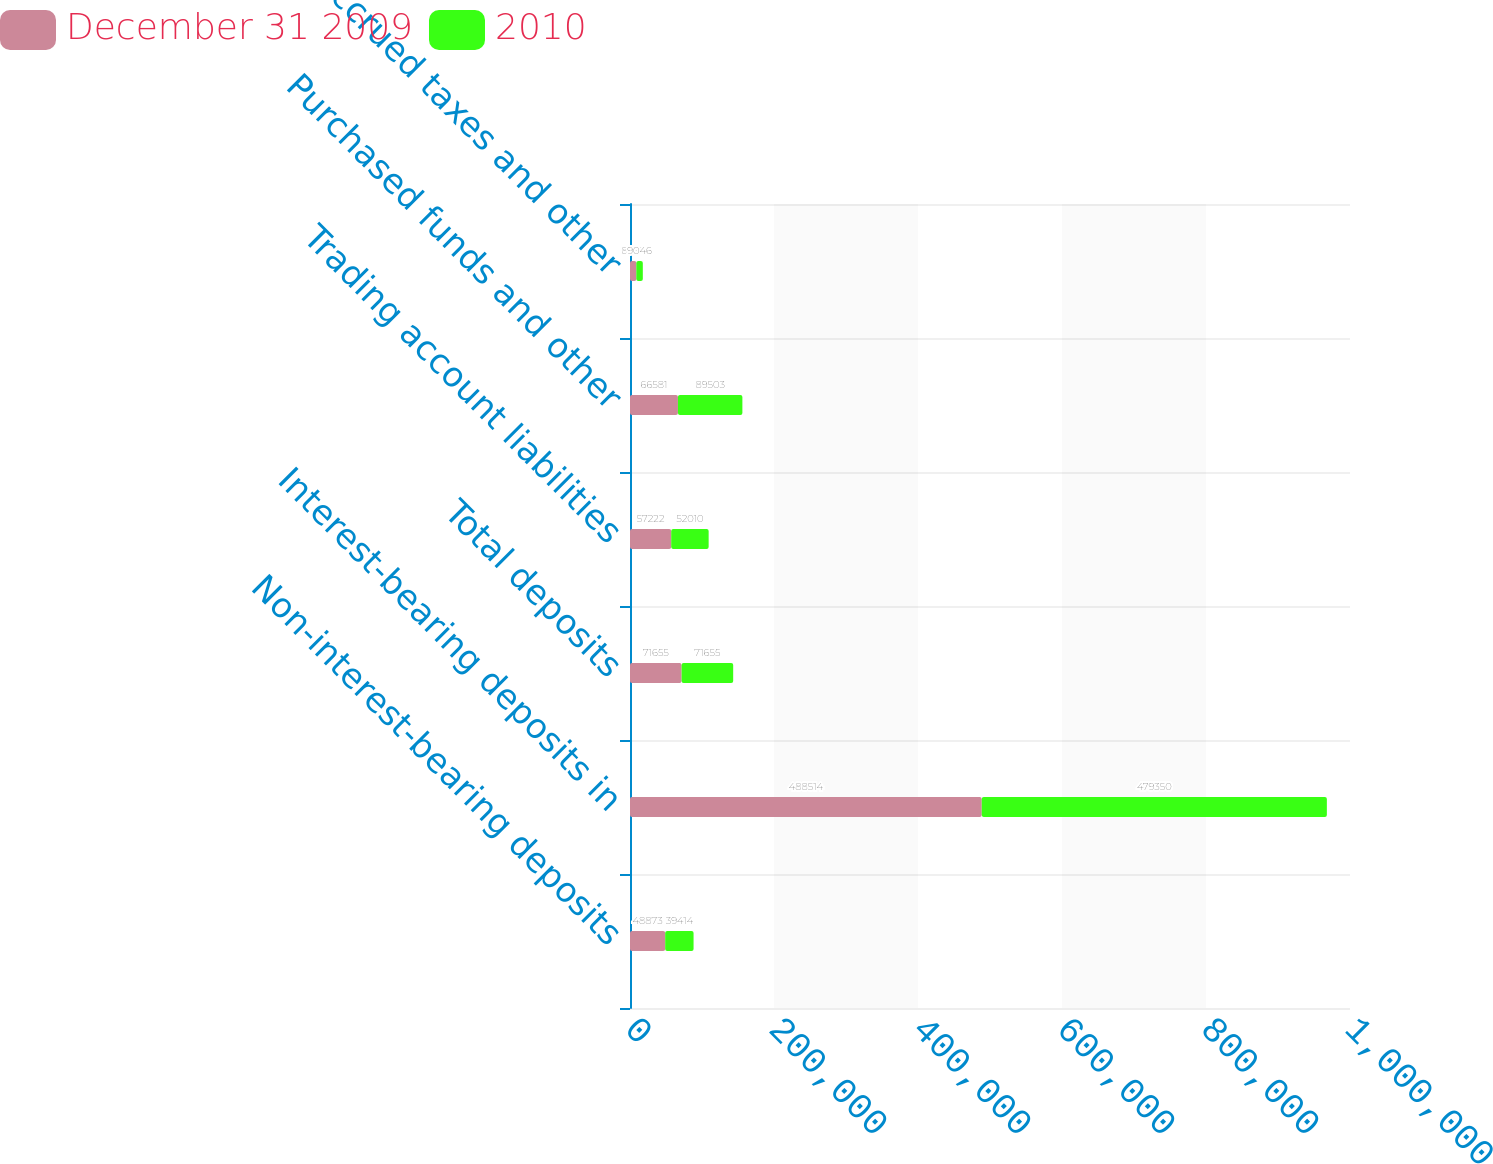<chart> <loc_0><loc_0><loc_500><loc_500><stacked_bar_chart><ecel><fcel>Non-interest-bearing deposits<fcel>Interest-bearing deposits in<fcel>Total deposits<fcel>Trading account liabilities<fcel>Purchased funds and other<fcel>Accrued taxes and other<nl><fcel>December 31 2009<fcel>48873<fcel>488514<fcel>71655<fcel>57222<fcel>66581<fcel>8758<nl><fcel>2010<fcel>39414<fcel>479350<fcel>71655<fcel>52010<fcel>89503<fcel>9046<nl></chart> 